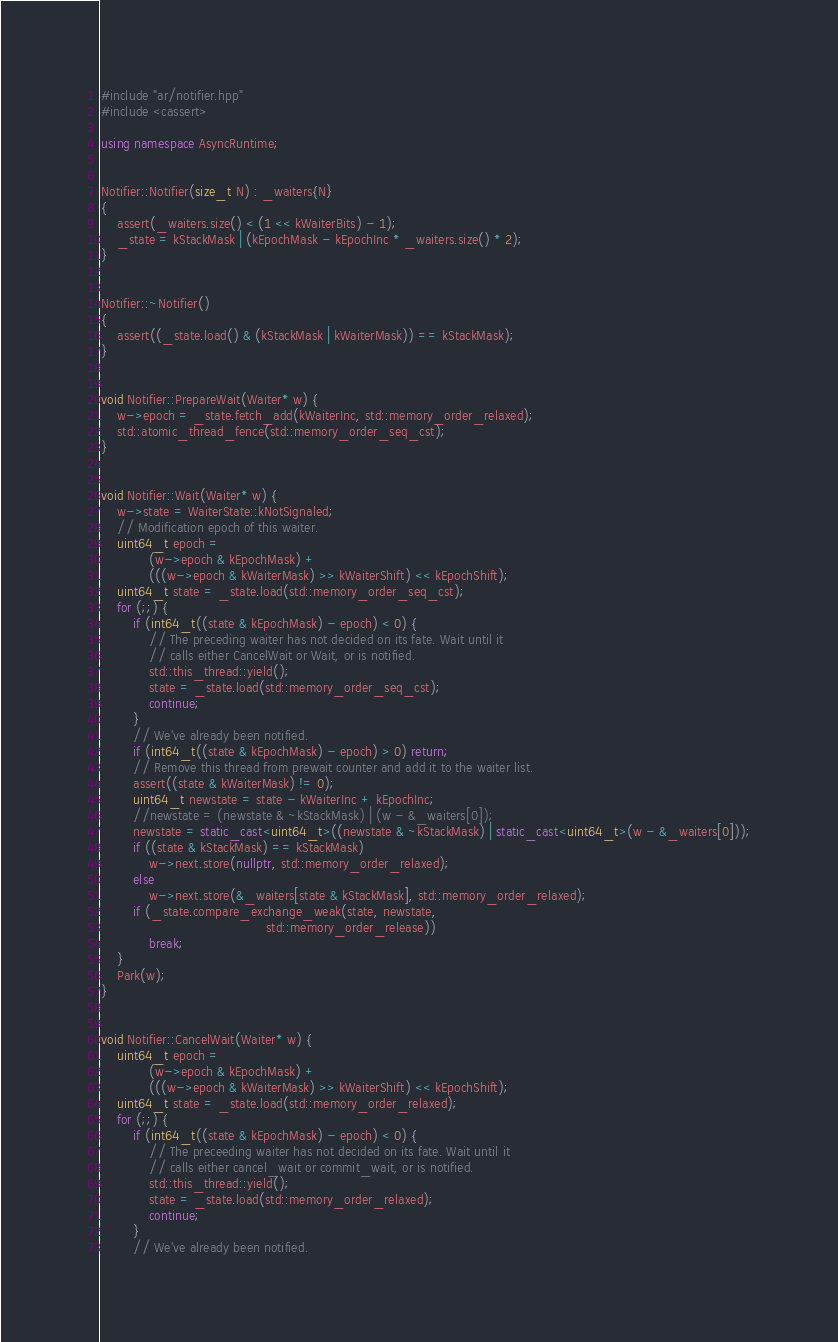Convert code to text. <code><loc_0><loc_0><loc_500><loc_500><_C++_>#include "ar/notifier.hpp"
#include <cassert>

using namespace AsyncRuntime;


Notifier::Notifier(size_t N) : _waiters{N}
{
    assert(_waiters.size() < (1 << kWaiterBits) - 1);
    _state = kStackMask | (kEpochMask - kEpochInc * _waiters.size() * 2);
}


Notifier::~Notifier()
{
    assert((_state.load() & (kStackMask | kWaiterMask)) == kStackMask);
}


void Notifier::PrepareWait(Waiter* w) {
    w->epoch = _state.fetch_add(kWaiterInc, std::memory_order_relaxed);
    std::atomic_thread_fence(std::memory_order_seq_cst);
}


void Notifier::Wait(Waiter* w) {
    w->state = WaiterState::kNotSignaled;
    // Modification epoch of this waiter.
    uint64_t epoch =
            (w->epoch & kEpochMask) +
            (((w->epoch & kWaiterMask) >> kWaiterShift) << kEpochShift);
    uint64_t state = _state.load(std::memory_order_seq_cst);
    for (;;) {
        if (int64_t((state & kEpochMask) - epoch) < 0) {
            // The preceding waiter has not decided on its fate. Wait until it
            // calls either CancelWait or Wait, or is notified.
            std::this_thread::yield();
            state = _state.load(std::memory_order_seq_cst);
            continue;
        }
        // We've already been notified.
        if (int64_t((state & kEpochMask) - epoch) > 0) return;
        // Remove this thread from prewait counter and add it to the waiter list.
        assert((state & kWaiterMask) != 0);
        uint64_t newstate = state - kWaiterInc + kEpochInc;
        //newstate = (newstate & ~kStackMask) | (w - &_waiters[0]);
        newstate = static_cast<uint64_t>((newstate & ~kStackMask) | static_cast<uint64_t>(w - &_waiters[0]));
        if ((state & kStackMask) == kStackMask)
            w->next.store(nullptr, std::memory_order_relaxed);
        else
            w->next.store(&_waiters[state & kStackMask], std::memory_order_relaxed);
        if (_state.compare_exchange_weak(state, newstate,
                                         std::memory_order_release))
            break;
    }
    Park(w);
}


void Notifier::CancelWait(Waiter* w) {
    uint64_t epoch =
            (w->epoch & kEpochMask) +
            (((w->epoch & kWaiterMask) >> kWaiterShift) << kEpochShift);
    uint64_t state = _state.load(std::memory_order_relaxed);
    for (;;) {
        if (int64_t((state & kEpochMask) - epoch) < 0) {
            // The preceeding waiter has not decided on its fate. Wait until it
            // calls either cancel_wait or commit_wait, or is notified.
            std::this_thread::yield();
            state = _state.load(std::memory_order_relaxed);
            continue;
        }
        // We've already been notified.</code> 